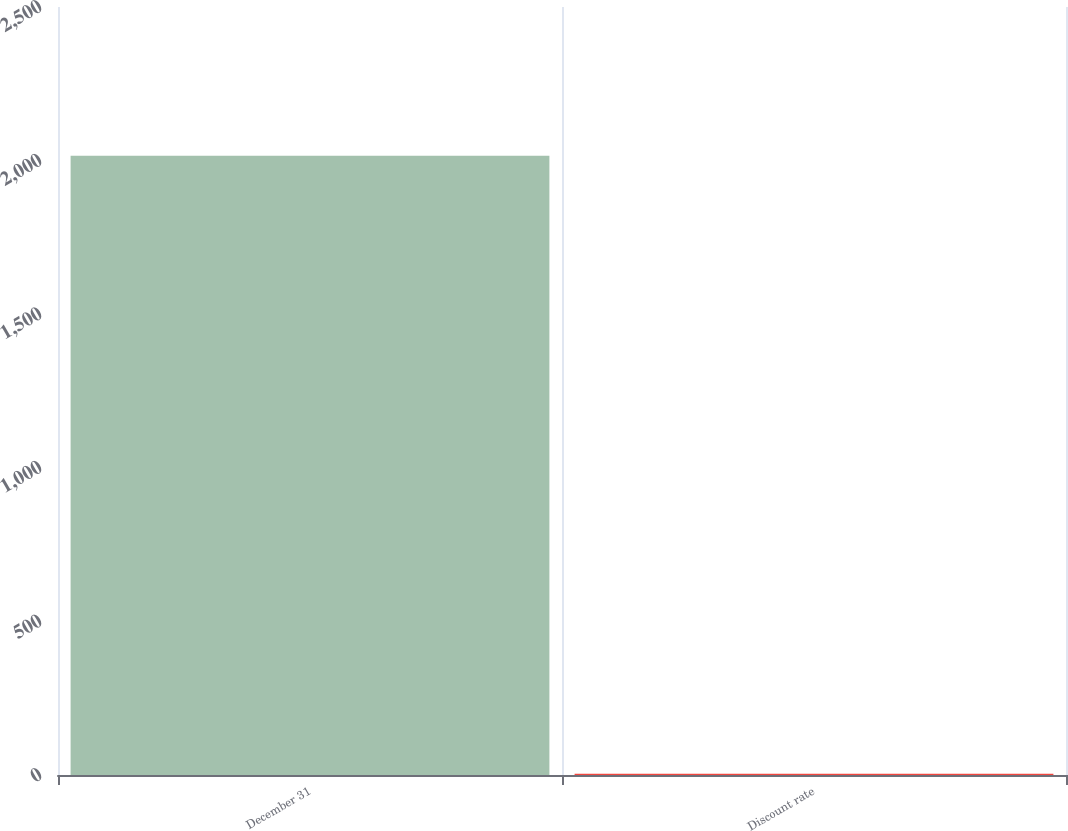Convert chart. <chart><loc_0><loc_0><loc_500><loc_500><bar_chart><fcel>December 31<fcel>Discount rate<nl><fcel>2016<fcel>4<nl></chart> 